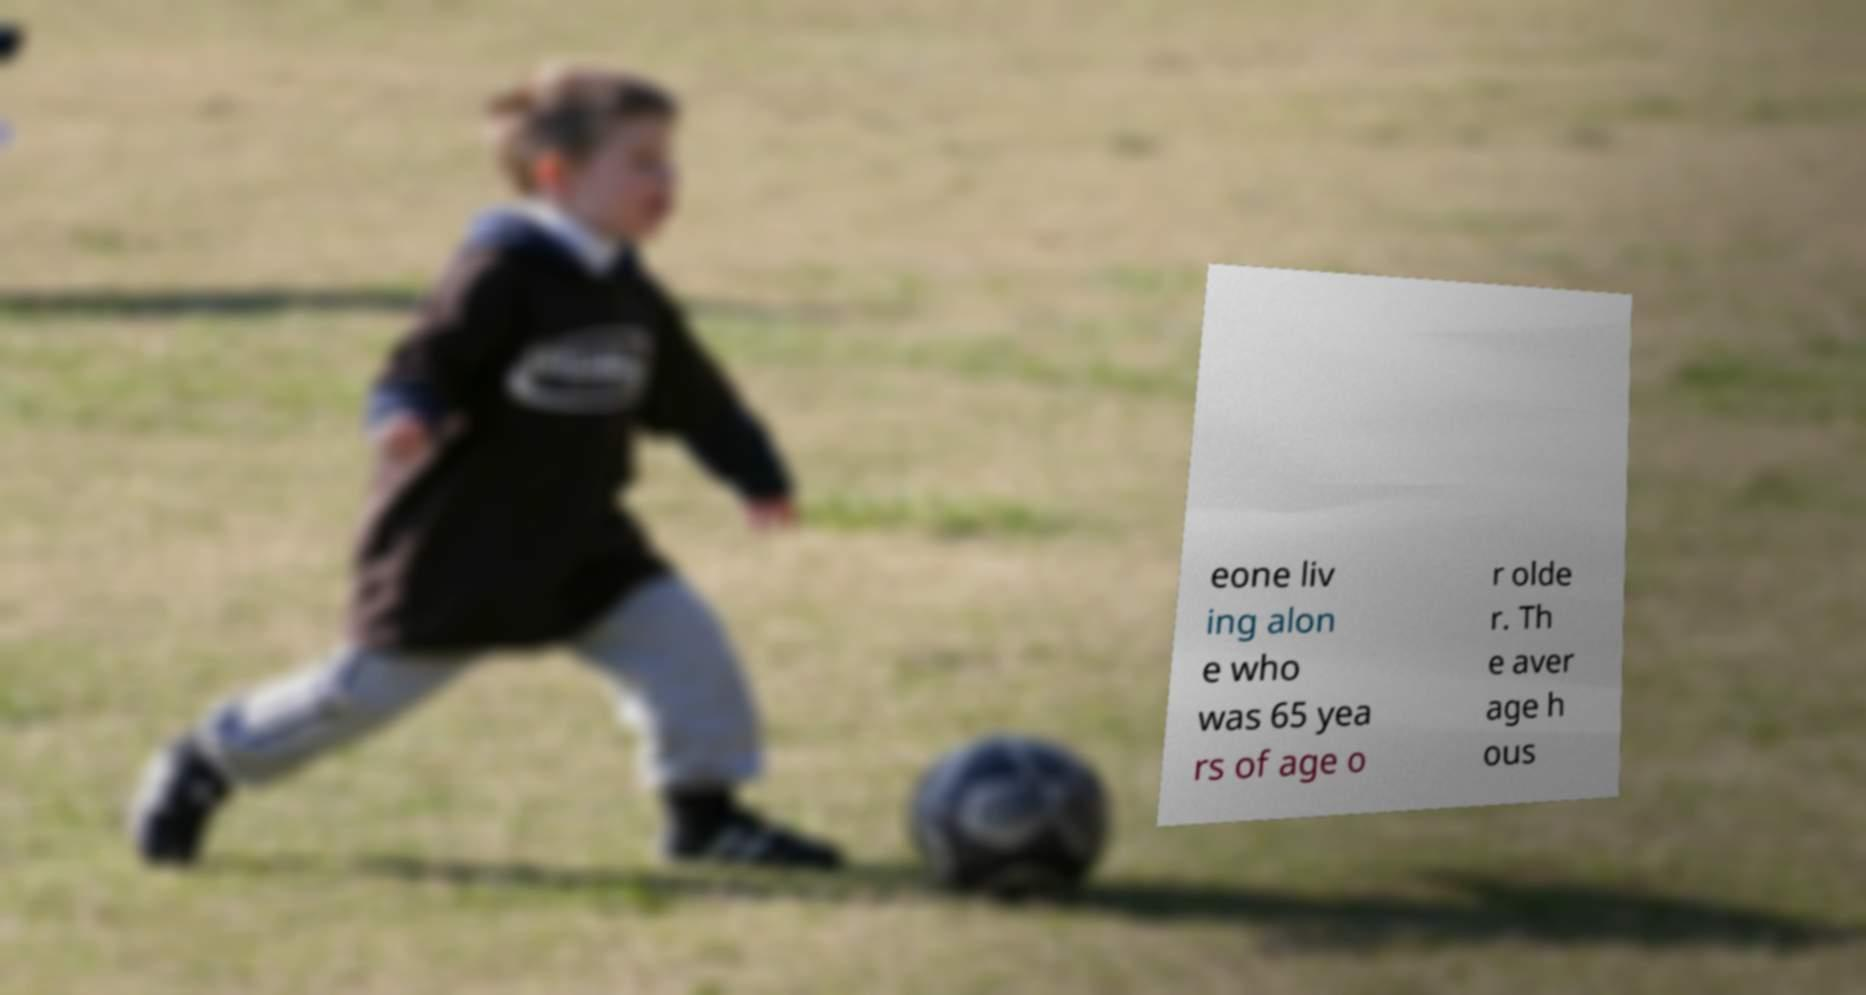There's text embedded in this image that I need extracted. Can you transcribe it verbatim? eone liv ing alon e who was 65 yea rs of age o r olde r. Th e aver age h ous 